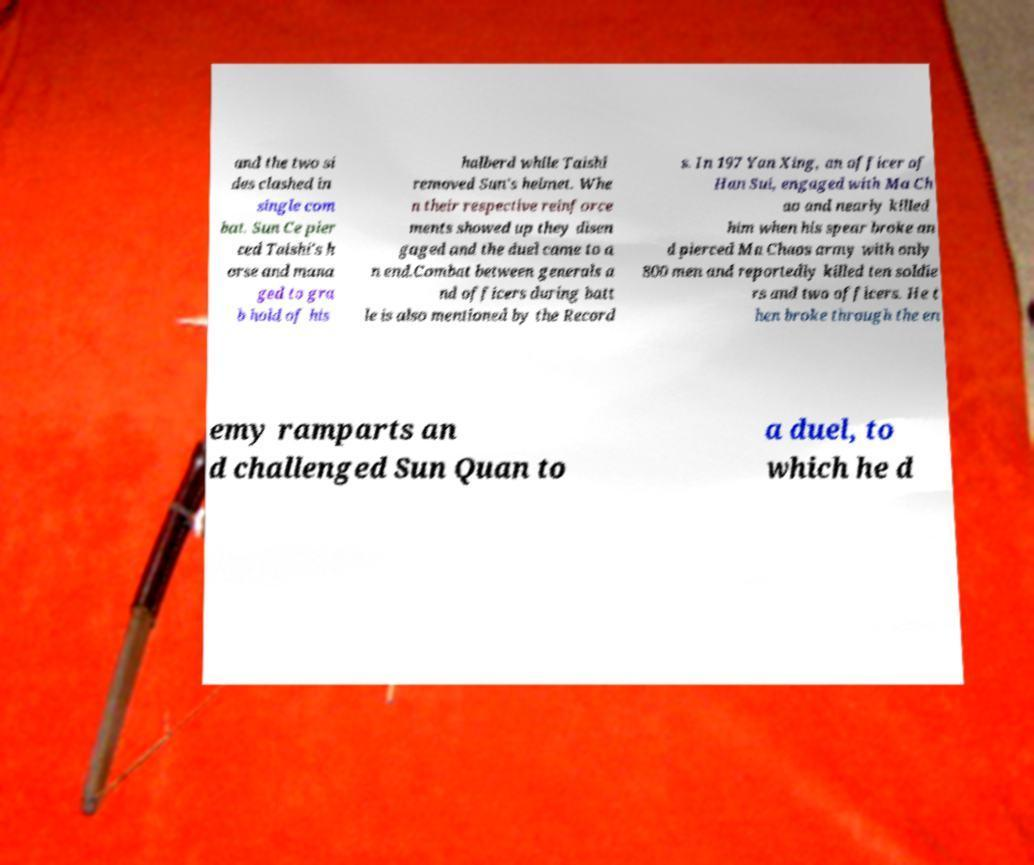Can you read and provide the text displayed in the image?This photo seems to have some interesting text. Can you extract and type it out for me? and the two si des clashed in single com bat. Sun Ce pier ced Taishi's h orse and mana ged to gra b hold of his halberd while Taishi removed Sun's helmet. Whe n their respective reinforce ments showed up they disen gaged and the duel came to a n end.Combat between generals a nd officers during batt le is also mentioned by the Record s. In 197 Yan Xing, an officer of Han Sui, engaged with Ma Ch ao and nearly killed him when his spear broke an d pierced Ma Chaos army with only 800 men and reportedly killed ten soldie rs and two officers. He t hen broke through the en emy ramparts an d challenged Sun Quan to a duel, to which he d 